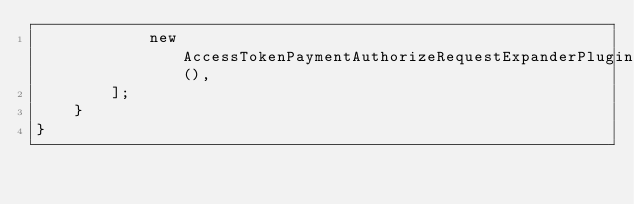<code> <loc_0><loc_0><loc_500><loc_500><_PHP_>            new AccessTokenPaymentAuthorizeRequestExpanderPlugin(),
        ];
    }
}
</code> 